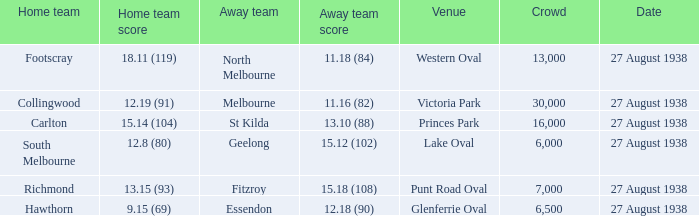Which away team scored 12.18 (90)? Essendon. 